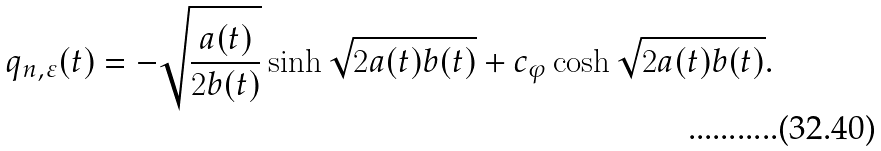<formula> <loc_0><loc_0><loc_500><loc_500>q _ { n , \varepsilon } ( t ) = - \sqrt { \frac { a ( t ) } { 2 b ( t ) } } \sinh \sqrt { 2 a ( t ) b ( t ) } + c _ { \varphi } \cosh \sqrt { 2 a ( t ) b ( t ) } .</formula> 